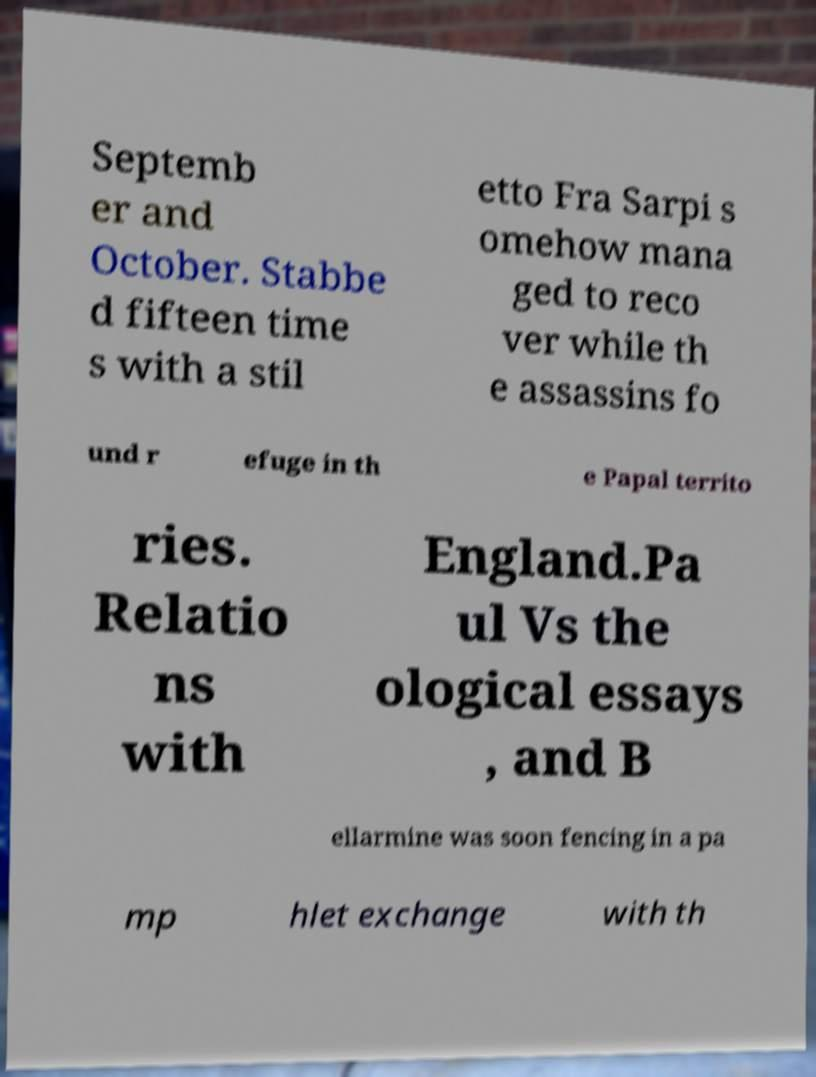I need the written content from this picture converted into text. Can you do that? Septemb er and October. Stabbe d fifteen time s with a stil etto Fra Sarpi s omehow mana ged to reco ver while th e assassins fo und r efuge in th e Papal territo ries. Relatio ns with England.Pa ul Vs the ological essays , and B ellarmine was soon fencing in a pa mp hlet exchange with th 